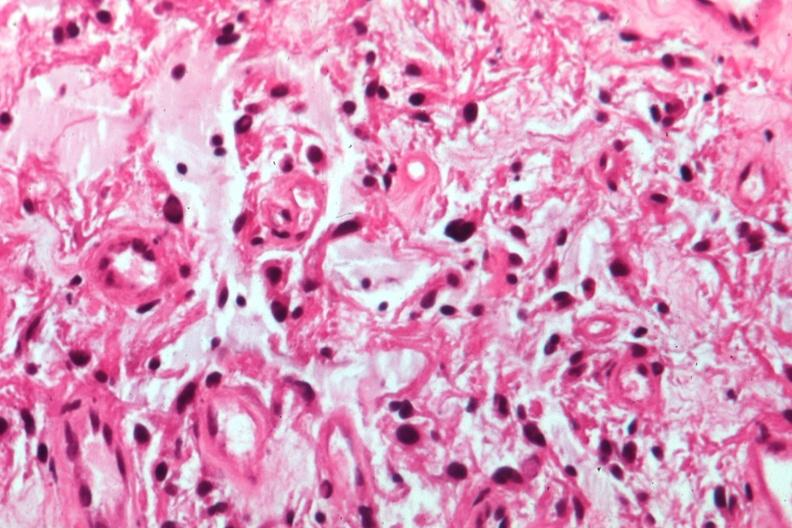s eye present?
Answer the question using a single word or phrase. Yes 